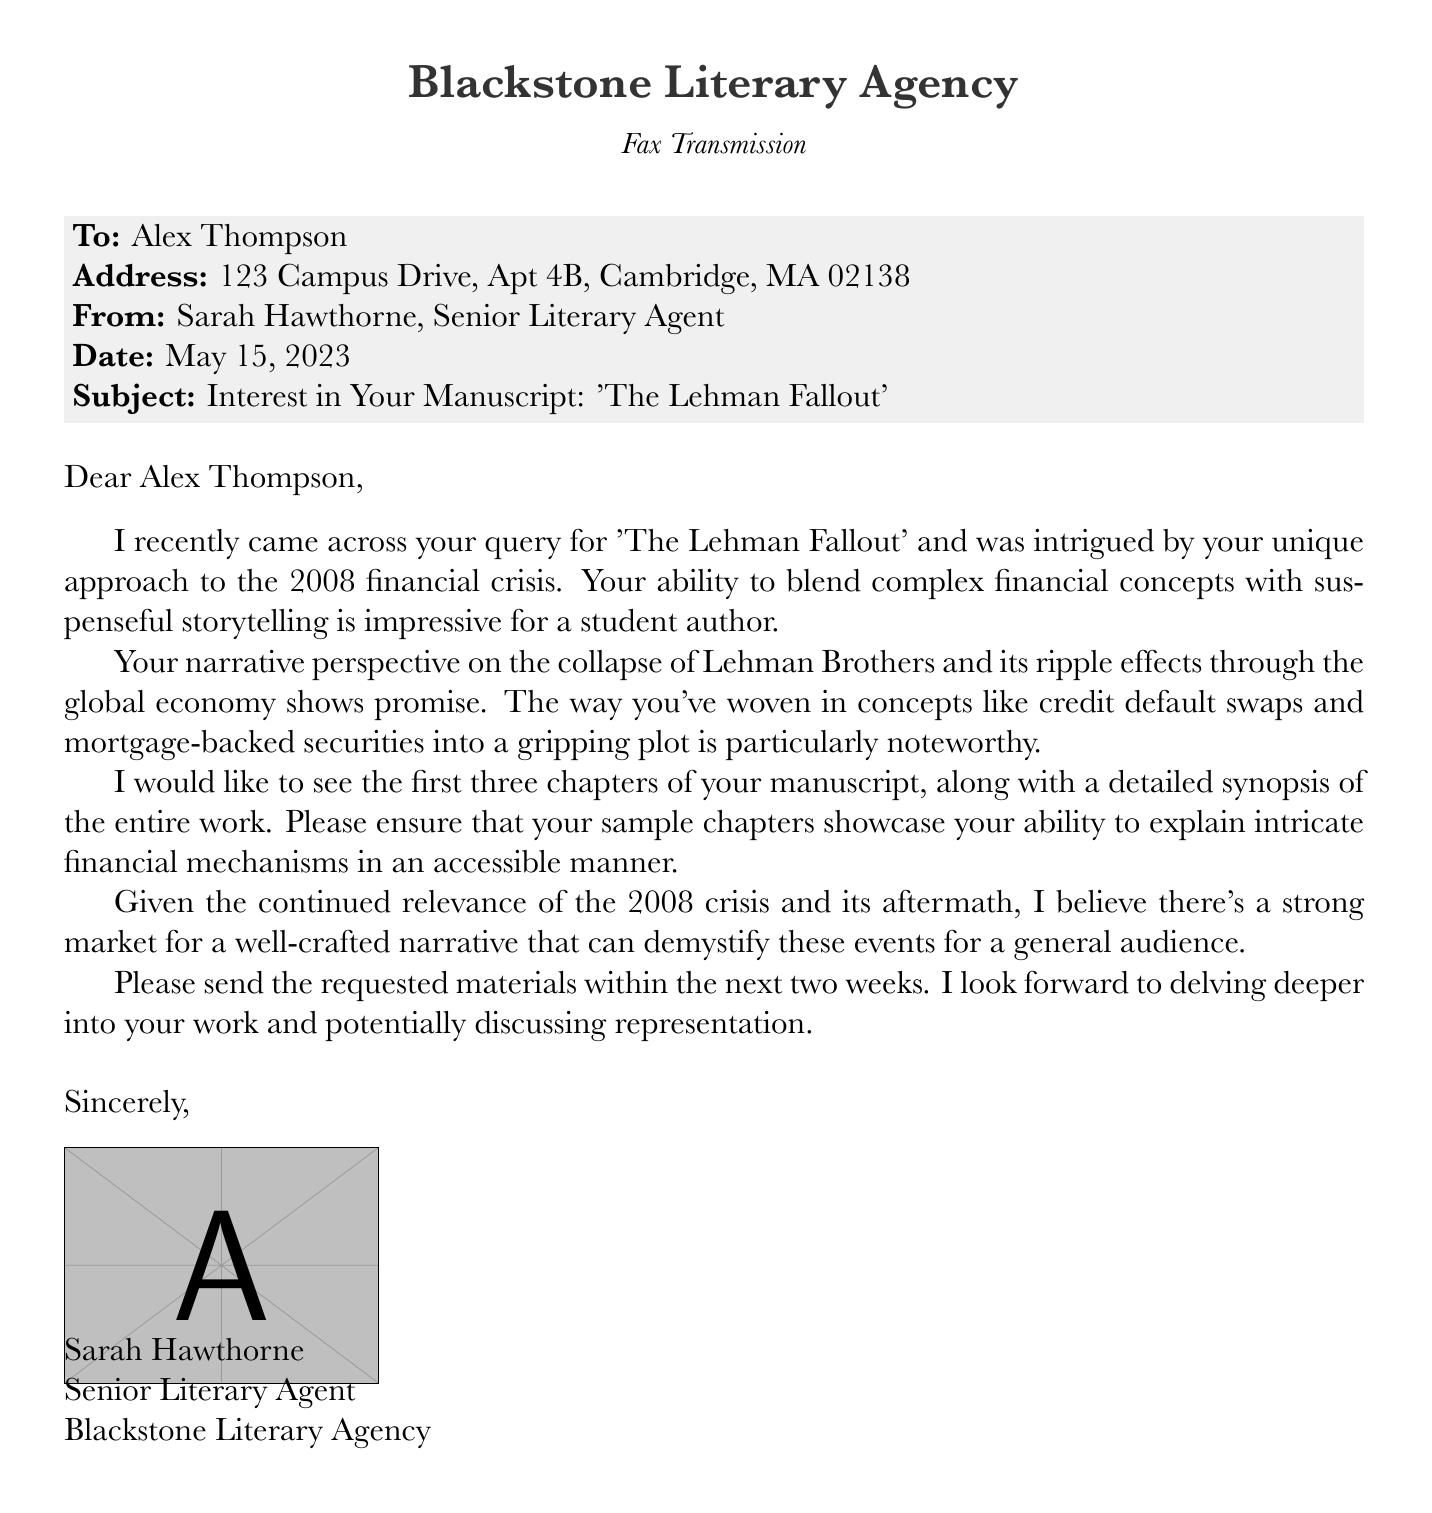What is the name of the manuscript? The manuscript title is stated in the subject line of the fax: 'The Lehman Fallout'.
Answer: 'The Lehman Fallout' Who is the sender of the fax? The sender's name and title are included at the bottom of the document.
Answer: Sarah Hawthorne What is the date of the fax transmission? The date is explicitly mentioned in the fax.
Answer: May 15, 2023 What specific materials are requested from the author? The fax outlines the requested materials in a detailed manner.
Answer: The first three chapters and a detailed synopsis What unique aspect of the author's writing does the agent mention? The agent provides a direct commentary on the author's skills in the fax.
Answer: Blending complex financial concepts with suspenseful storytelling How long does the author have to send the requested materials? The deadline for sending materials is specified in the closing remarks.
Answer: Two weeks What financial concepts are highlighted in the manuscript? The agent references specific financial terms that are woven into the plot.
Answer: Credit default swaps and mortgage-backed securities What is the name of the literary agency? The agency is clearly stated at the beginning of the document.
Answer: Blackstone Literary Agency What is the recipient's address? The recipient's address is provided in the fax's header.
Answer: 123 Campus Drive, Apt 4B, Cambridge, MA 02138 Why does the agent believe the manuscript is timely for the market? The agent discusses the relevance of the subject matter in the context of a larger economic event.
Answer: The continued relevance of the 2008 crisis and its aftermath 